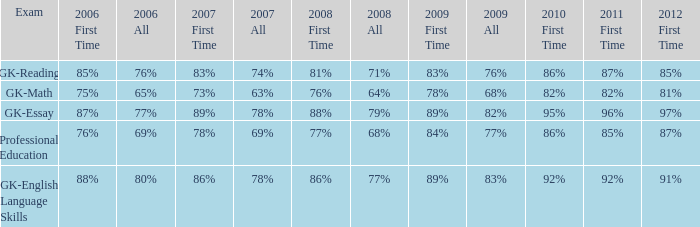What is the percentage for first time 2011 when the first time in 2009 is 68%? 82%. 